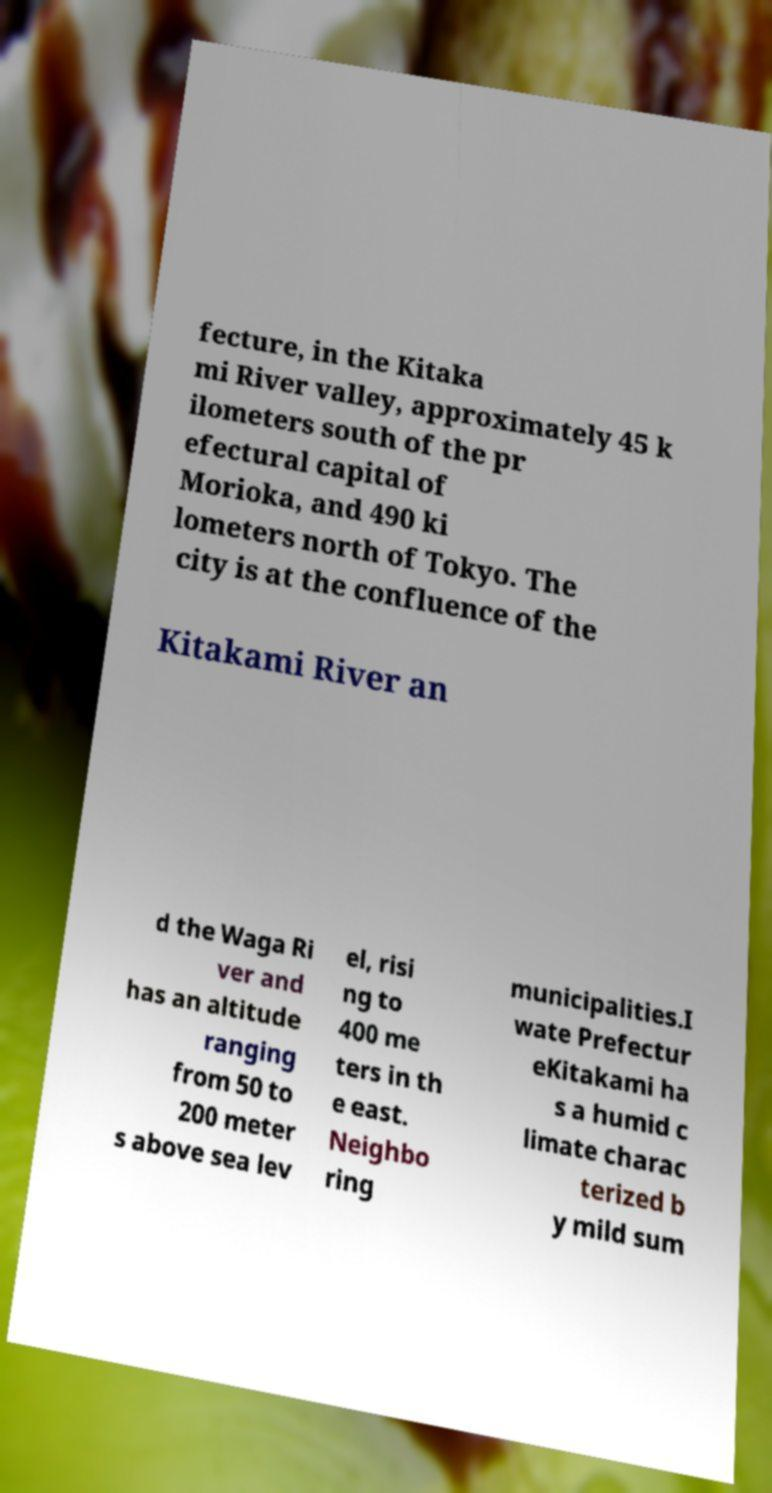Can you accurately transcribe the text from the provided image for me? fecture, in the Kitaka mi River valley, approximately 45 k ilometers south of the pr efectural capital of Morioka, and 490 ki lometers north of Tokyo. The city is at the confluence of the Kitakami River an d the Waga Ri ver and has an altitude ranging from 50 to 200 meter s above sea lev el, risi ng to 400 me ters in th e east. Neighbo ring municipalities.I wate Prefectur eKitakami ha s a humid c limate charac terized b y mild sum 